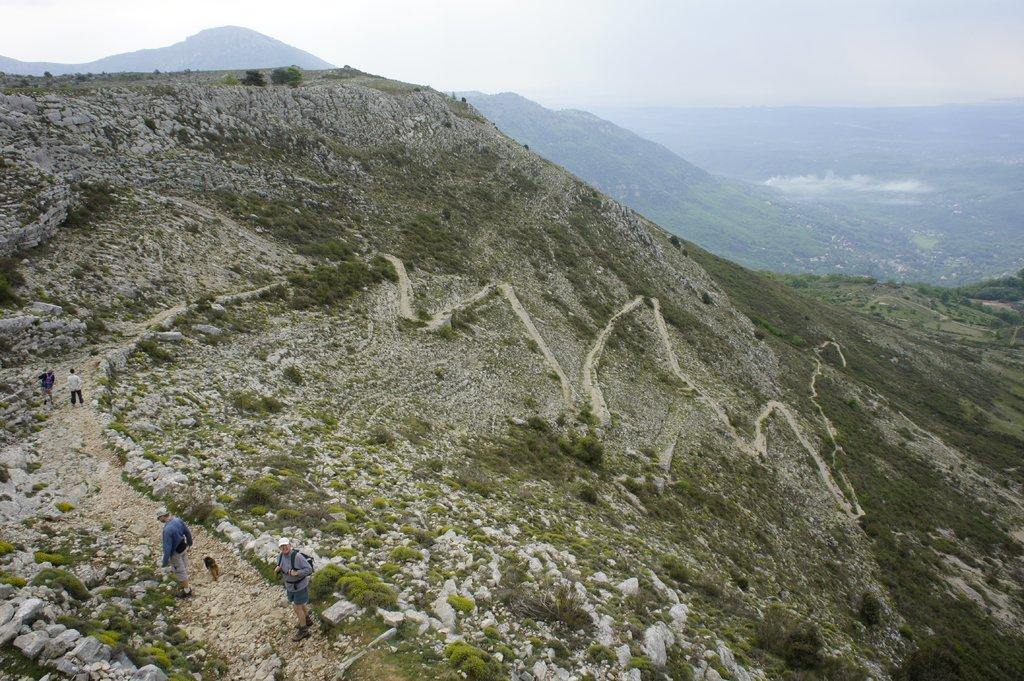What type of landscape is depicted in the image? There are hills in the image. Are there any people present in the image? Yes, there are people in the image. What is visible at the top of the image? The sky is visible at the top of the image. Reasoning: Let' Let's think step by step in order to produce the conversation. We start by identifying the main landscape feature in the image, which is the hills. Then, we mention the presence of people in the image, as they are a significant element. Finally, we describe the sky's visibility at the top of the image to provide context about the weather or time of day. Absurd Question/Answer: What type of cakes are being served to the people in the image? There is no mention of cakes or any food items in the image; it only features hills and people. 